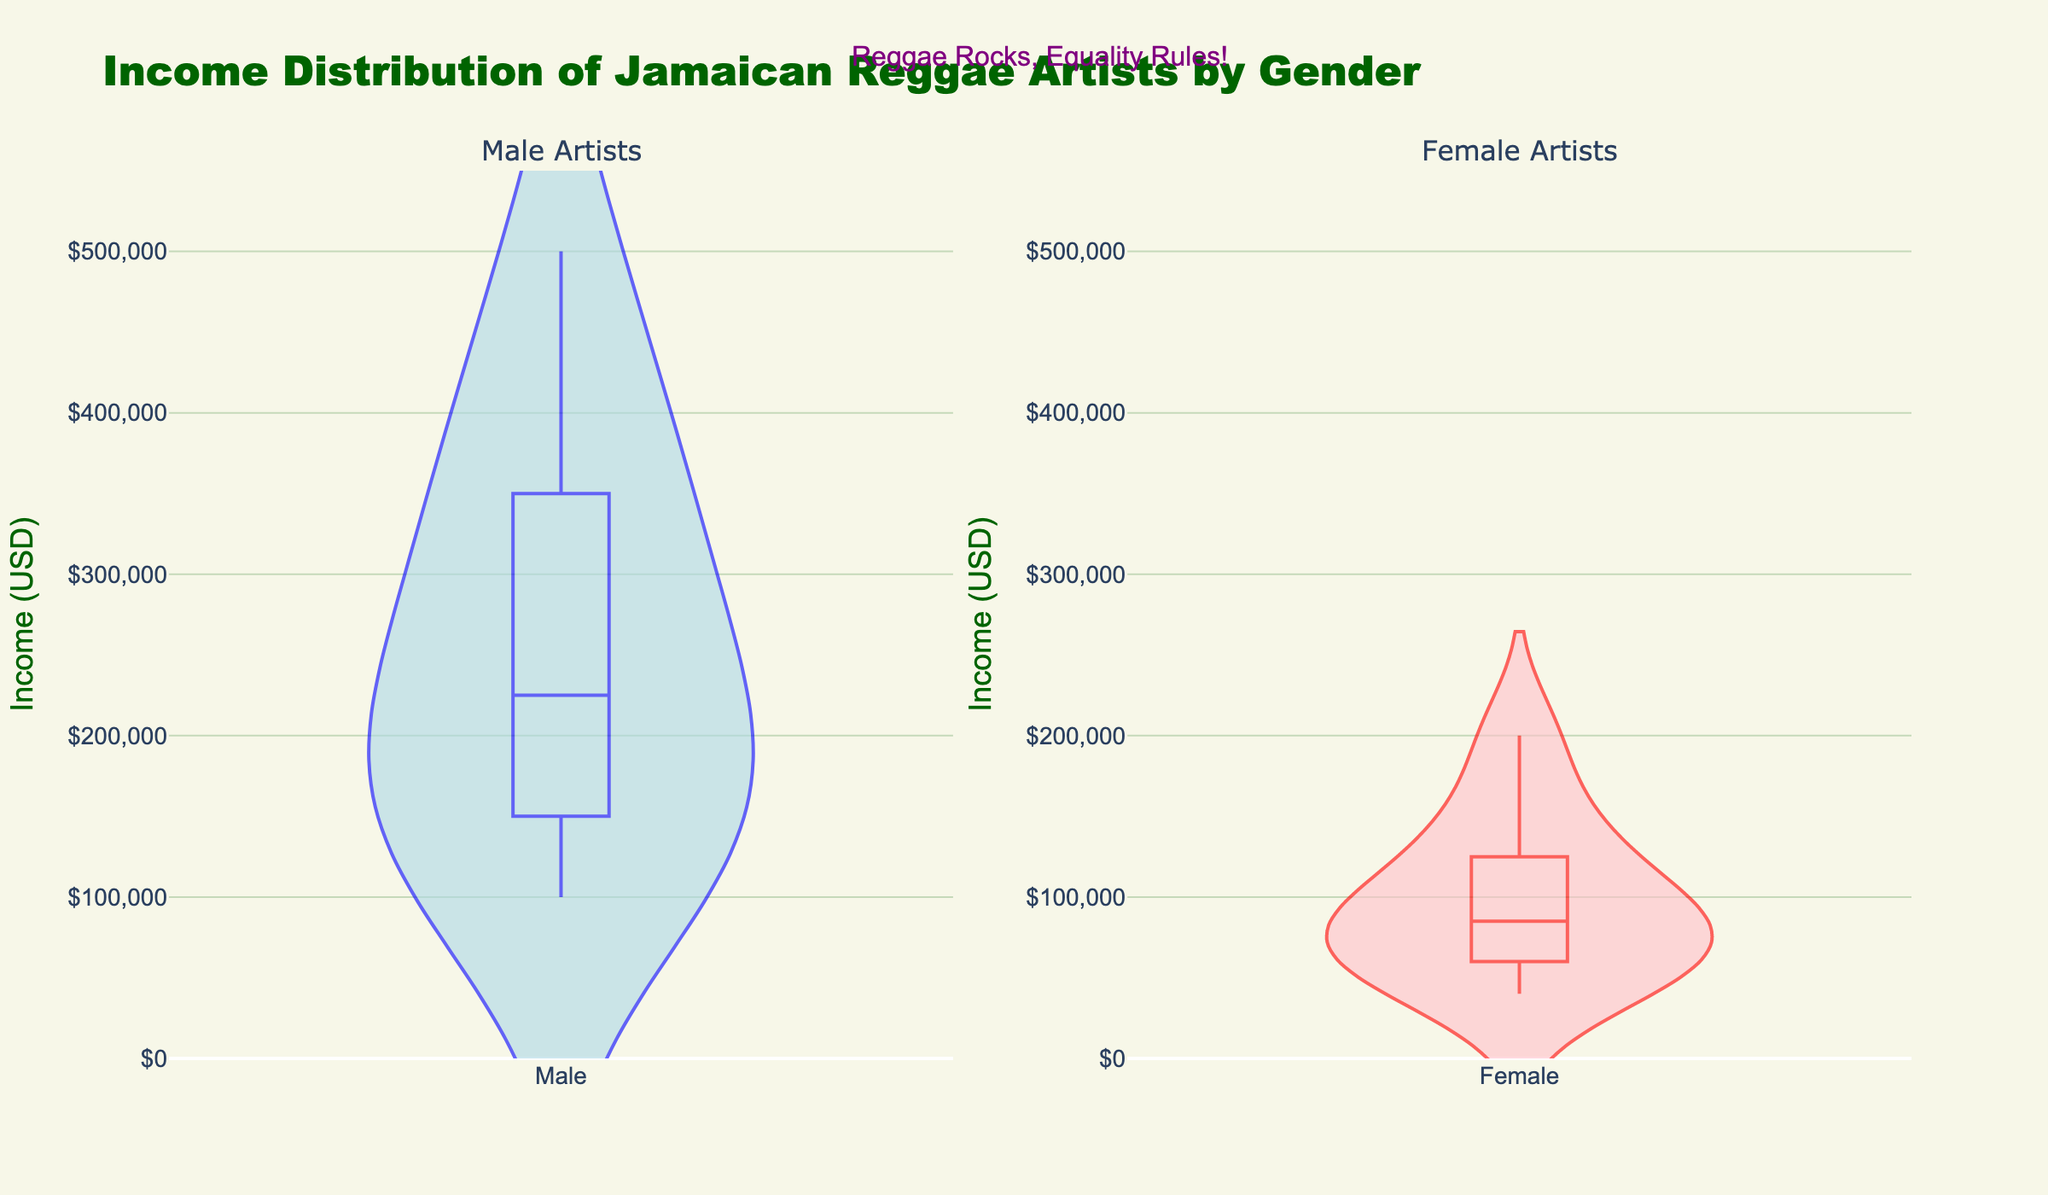Which gender of artists has the higher median income? Looking at the violin plots, the central box indicates the median income. The male artists' box is higher up on the plot compared to the female artists' box, indicating that male artists have a higher median income.
Answer: Male What's the title of the figure? The title is positioned at the top of the visualization and reads "Income Distribution of Jamaican Reggae Artists by Gender."
Answer: Income Distribution of Jamaican Reggae Artists by Gender Which gender has a broader range of income? Range can be observed by the length of the violin plot from the bottom to the top. The male artists' plot extends higher, indicating a broader range of income compared to female artists.
Answer: Male What colors are used for the male and female violin plots? The male violin plot is represented by a light blue fill with a blue line, and the female violin plot is represented by a pink fill with a red line.
Answer: Blue and pink What is the lowest income recorded for female artists? The lowest point on the female violin plot marks the minimum income, which in this case is $40,000.
Answer: $40,000 What annotation is included in the figure? The annotation in the figure is located above the plots, intended to highlight the message, "Reggae Rocks, Equality Rules!"
Answer: Reggae Rocks, Equality Rules! How do the upper limits of income distribution compare between genders? The maximum value on the male violin plot reaches approximately $500,000, while the female plot reaches around $200,000. This indicates that male artists have a higher upper limit of income.
Answer: Male artists have a higher upper limit Which gender has a higher density of data points in the lower income range? Density is indicated by the width of the violin plots. The female plot is wider at the lower range, suggesting a higher density of lower income data points among female artists.
Answer: Female What is the price range displayed on the y-axis, and how are the intervals formatted? The y-axis shows a range from $0 to $550,000, with intervals formatted in thousands, indicated as "$,.0f".
Answer: $0 to $550,000, intervals in thousands 